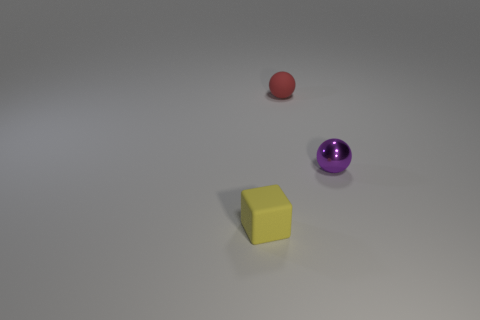Add 1 yellow things. How many objects exist? 4 Subtract all balls. How many objects are left? 1 Subtract 1 spheres. How many spheres are left? 1 Subtract all blue spheres. Subtract all cyan blocks. How many spheres are left? 2 Subtract all green spheres. How many blue blocks are left? 0 Subtract all purple metal spheres. Subtract all small matte objects. How many objects are left? 0 Add 3 tiny yellow rubber blocks. How many tiny yellow rubber blocks are left? 4 Add 1 big blue cubes. How many big blue cubes exist? 1 Subtract 0 purple cylinders. How many objects are left? 3 